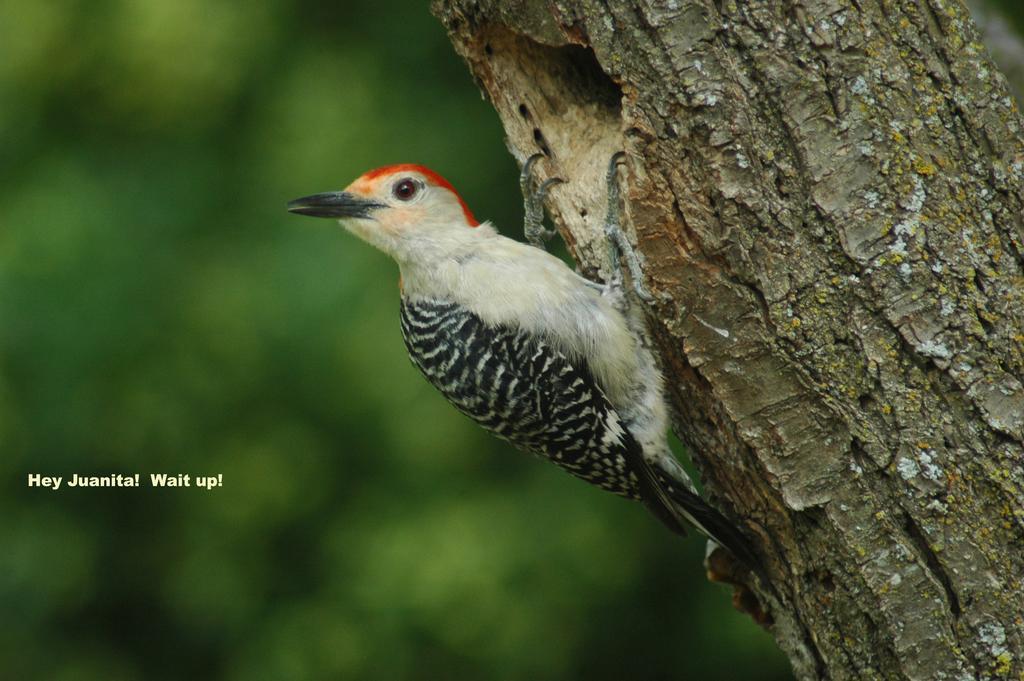Could you give a brief overview of what you see in this image? In the picture there is a small bird standing on the tree trunk and the background of the bird is blue. 